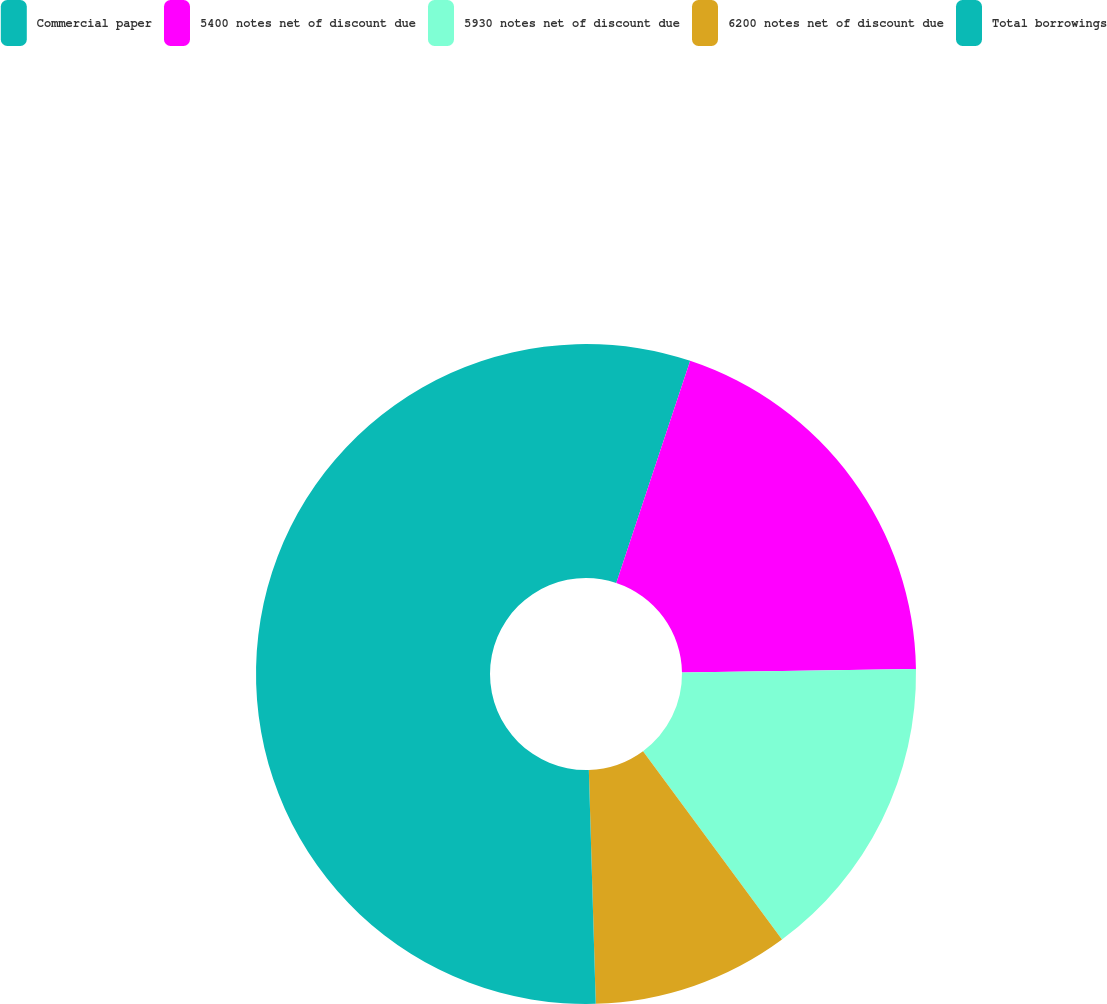<chart> <loc_0><loc_0><loc_500><loc_500><pie_chart><fcel>Commercial paper<fcel>5400 notes net of discount due<fcel>5930 notes net of discount due<fcel>6200 notes net of discount due<fcel>Total borrowings<nl><fcel>5.11%<fcel>19.65%<fcel>15.12%<fcel>9.65%<fcel>50.47%<nl></chart> 